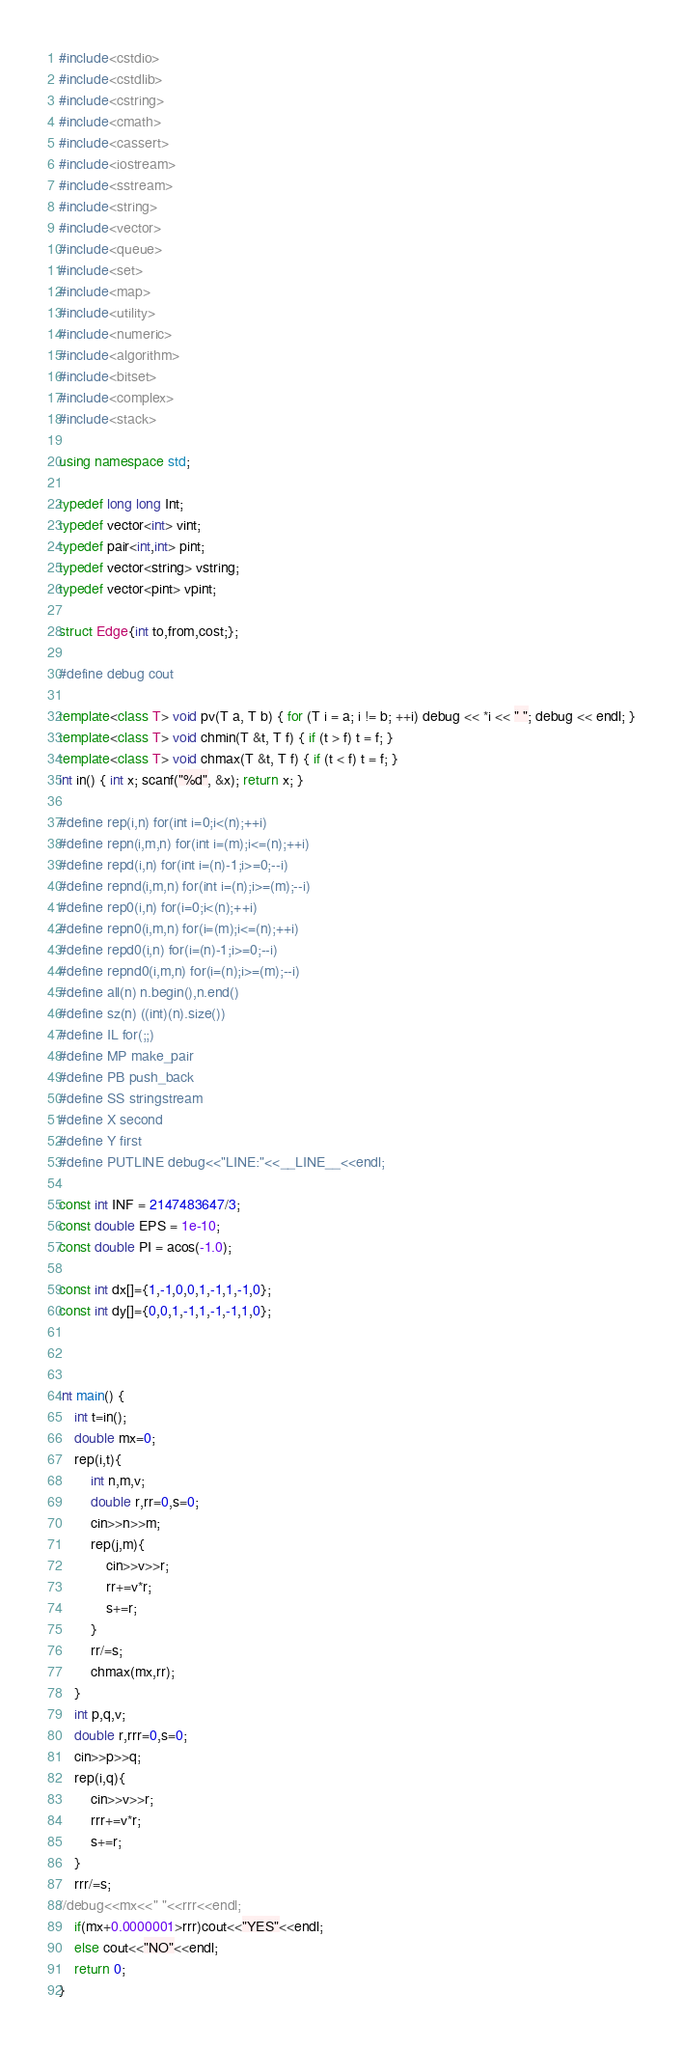<code> <loc_0><loc_0><loc_500><loc_500><_C++_>#include<cstdio>
#include<cstdlib>
#include<cstring>
#include<cmath>
#include<cassert>
#include<iostream>
#include<sstream>
#include<string>
#include<vector>
#include<queue>
#include<set>
#include<map>
#include<utility>
#include<numeric>
#include<algorithm>
#include<bitset>
#include<complex>
#include<stack>

using namespace std;

typedef long long Int;
typedef vector<int> vint;
typedef pair<int,int> pint;
typedef vector<string> vstring;
typedef vector<pint> vpint;

struct Edge{int to,from,cost;};

#define debug cout

template<class T> void pv(T a, T b) { for (T i = a; i != b; ++i) debug << *i << " "; debug << endl; }
template<class T> void chmin(T &t, T f) { if (t > f) t = f; }
template<class T> void chmax(T &t, T f) { if (t < f) t = f; }
int in() { int x; scanf("%d", &x); return x; }

#define rep(i,n) for(int i=0;i<(n);++i)
#define repn(i,m,n) for(int i=(m);i<=(n);++i)
#define repd(i,n) for(int i=(n)-1;i>=0;--i)
#define repnd(i,m,n) for(int i=(n);i>=(m);--i)
#define rep0(i,n) for(i=0;i<(n);++i)
#define repn0(i,m,n) for(i=(m);i<=(n);++i)
#define repd0(i,n) for(i=(n)-1;i>=0;--i)
#define repnd0(i,m,n) for(i=(n);i>=(m);--i)
#define all(n) n.begin(),n.end()
#define sz(n) ((int)(n).size())
#define IL for(;;)
#define MP make_pair
#define PB push_back
#define SS stringstream
#define X second
#define Y first
#define PUTLINE debug<<"LINE:"<<__LINE__<<endl;

const int INF = 2147483647/3;
const double EPS = 1e-10;
const double PI = acos(-1.0);

const int dx[]={1,-1,0,0,1,-1,1,-1,0};
const int dy[]={0,0,1,-1,1,-1,-1,1,0};



int main() {
	int t=in();
	double mx=0;
	rep(i,t){
		int n,m,v;
		double r,rr=0,s=0;
		cin>>n>>m;
		rep(j,m){
			cin>>v>>r;
			rr+=v*r;
			s+=r;
		}
		rr/=s;
		chmax(mx,rr);
	}
	int p,q,v;
	double r,rrr=0,s=0;
	cin>>p>>q;
	rep(i,q){
		cin>>v>>r;
		rrr+=v*r;
		s+=r;
	}
	rrr/=s;
//debug<<mx<<" "<<rrr<<endl;
	if(mx+0.0000001>rrr)cout<<"YES"<<endl;
	else cout<<"NO"<<endl;
	return 0;
}</code> 